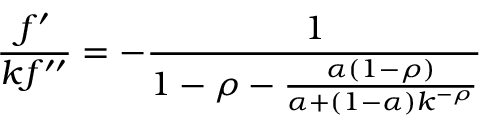Convert formula to latex. <formula><loc_0><loc_0><loc_500><loc_500>{ \frac { f ^ { \prime } } { k f ^ { \prime \prime } } } = - { \frac { 1 } { 1 - \rho - { \frac { \alpha ( 1 - \rho ) } { \alpha + ( 1 - \alpha ) k ^ { - \rho } } } } }</formula> 